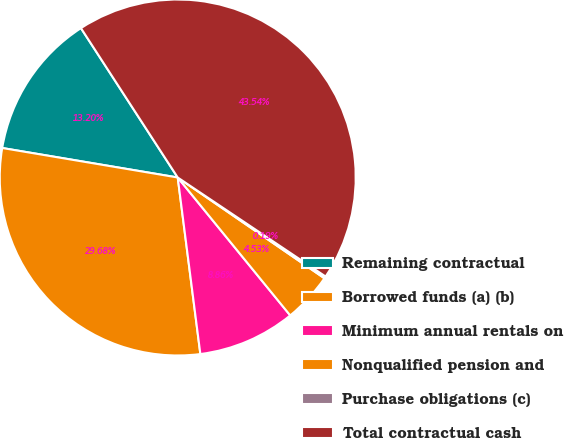<chart> <loc_0><loc_0><loc_500><loc_500><pie_chart><fcel>Remaining contractual<fcel>Borrowed funds (a) (b)<fcel>Minimum annual rentals on<fcel>Nonqualified pension and<fcel>Purchase obligations (c)<fcel>Total contractual cash<nl><fcel>13.2%<fcel>29.68%<fcel>8.86%<fcel>4.53%<fcel>0.19%<fcel>43.54%<nl></chart> 